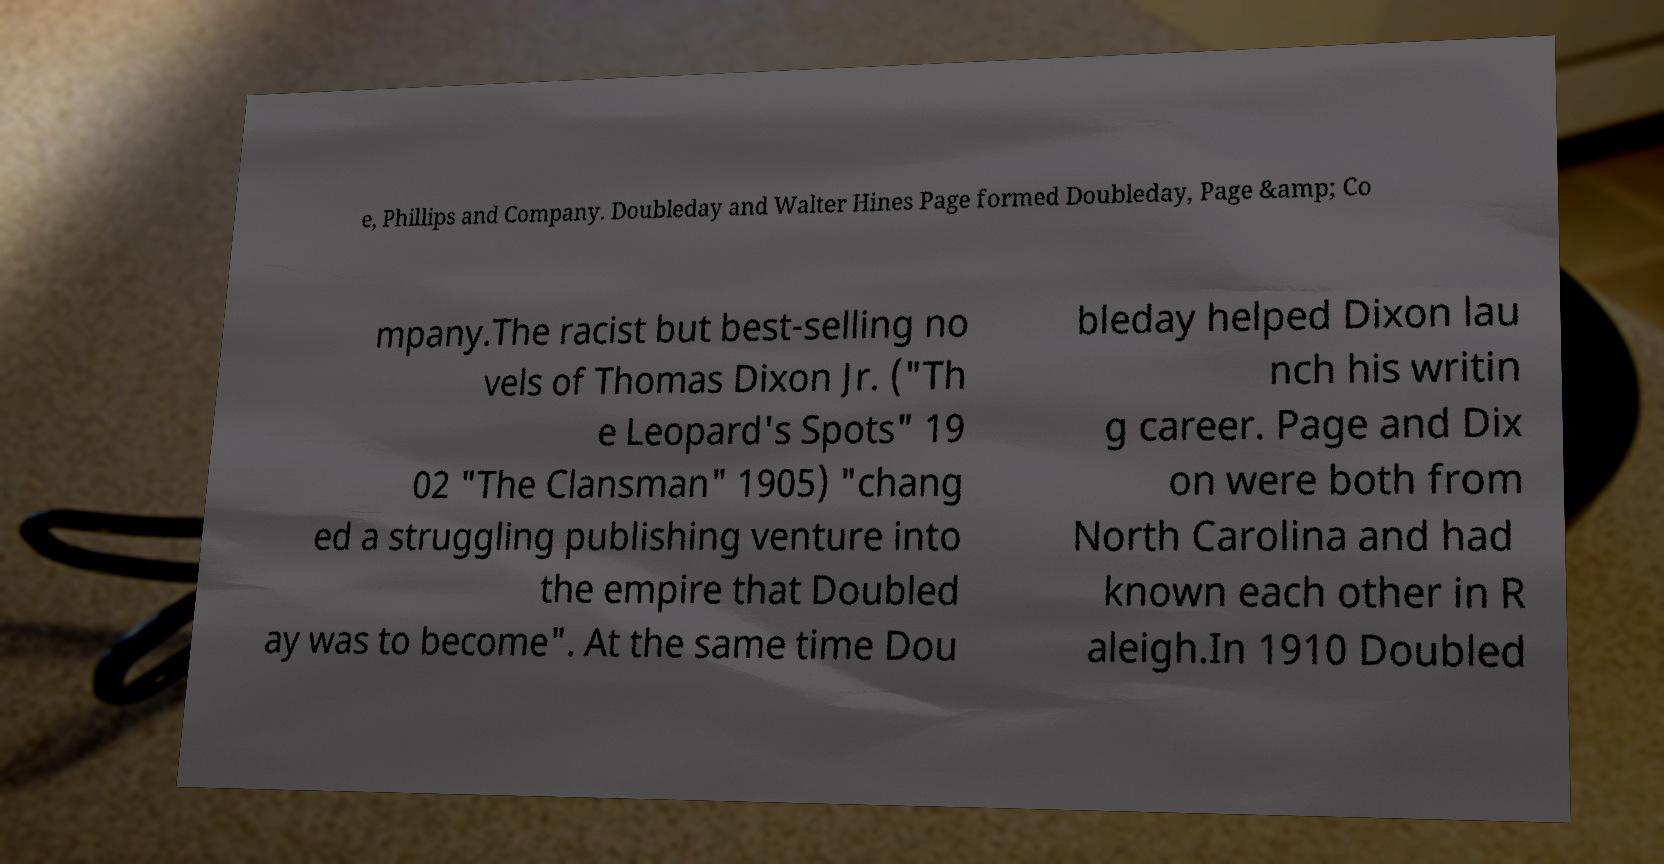Can you accurately transcribe the text from the provided image for me? e, Phillips and Company. Doubleday and Walter Hines Page formed Doubleday, Page &amp; Co mpany.The racist but best-selling no vels of Thomas Dixon Jr. ("Th e Leopard's Spots" 19 02 "The Clansman" 1905) "chang ed a struggling publishing venture into the empire that Doubled ay was to become". At the same time Dou bleday helped Dixon lau nch his writin g career. Page and Dix on were both from North Carolina and had known each other in R aleigh.In 1910 Doubled 